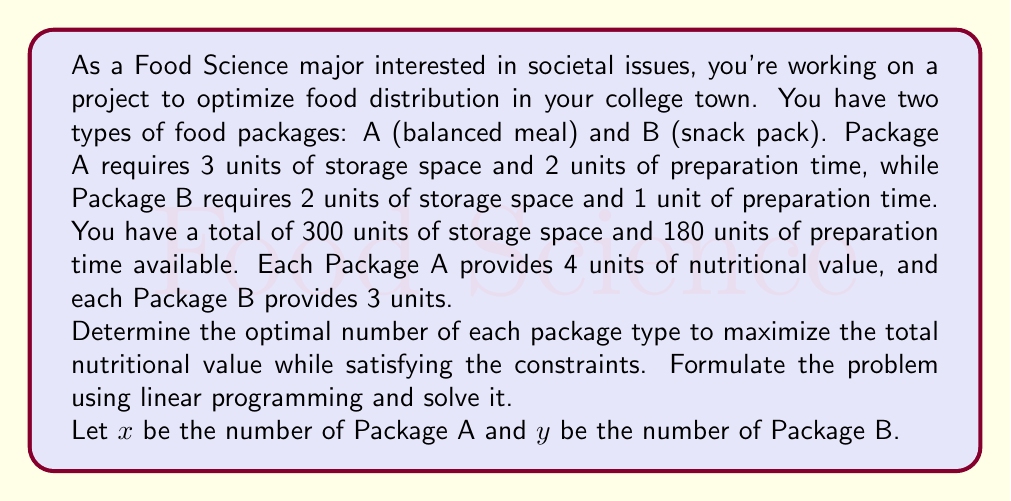Teach me how to tackle this problem. Let's approach this step-by-step:

1. Formulate the objective function:
   We want to maximize the total nutritional value.
   Objective function: $Z = 4x + 3y$

2. Identify the constraints:
   a. Storage space: $3x + 2y \leq 300$
   b. Preparation time: $2x + y \leq 180$
   c. Non-negativity: $x \geq 0, y \geq 0$

3. Graph the constraints:
   [asy]
   import geometry;
   
   size(200);
   
   xaxis("x", 0, 100, Arrow);
   yaxis("y", 0, 150, Arrow);
   
   draw((0,150)--(100,0), blue);
   draw((0,180)--(90,0), red);
   
   label("3x + 2y = 300", (50,75), blue);
   label("2x + y = 180", (45,90), red);
   
   fill((0,0)--(0,150)--(60,90)--(90,0)--cycle, palegreen+opacity(0.2));
   [/asy]

4. Identify the corner points of the feasible region:
   (0,0), (0,150), (60,90), (90,0)

5. Evaluate the objective function at each corner point:
   At (0,0): $Z = 4(0) + 3(0) = 0$
   At (0,150): $Z = 4(0) + 3(150) = 450$
   At (60,90): $Z = 4(60) + 3(90) = 510$
   At (90,0): $Z = 4(90) + 3(0) = 360$

6. The maximum value occurs at (60,90), so this is our optimal solution.

Therefore, to maximize the total nutritional value, we should produce 60 units of Package A and 90 units of Package B.
Answer: The optimal solution is to produce 60 units of Package A and 90 units of Package B, resulting in a maximum total nutritional value of 510 units. 